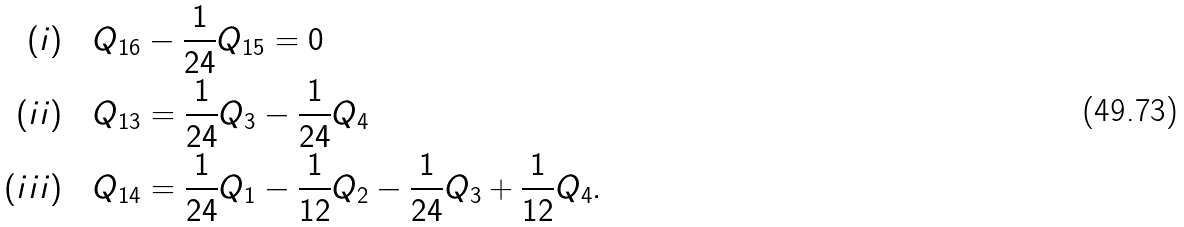<formula> <loc_0><loc_0><loc_500><loc_500>( i ) & \quad Q _ { 1 6 } - \frac { 1 } { 2 4 } { Q _ { 1 5 } } = 0 \\ ( i i ) & \quad Q _ { 1 3 } = \frac { 1 } { 2 4 } { Q _ { 3 } } - \frac { 1 } { 2 4 } { Q _ { 4 } } \\ ( i i i ) & \quad Q _ { 1 4 } = \frac { 1 } { 2 4 } { Q _ { 1 } } - \frac { 1 } { 1 2 } { Q _ { 2 } } - \frac { 1 } { 2 4 } { Q _ { 3 } } + \frac { 1 } { 1 2 } { Q _ { 4 } } .</formula> 